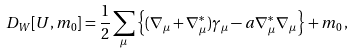<formula> <loc_0><loc_0><loc_500><loc_500>D _ { W } [ U , m _ { 0 } ] = \frac { 1 } { 2 } \sum _ { \mu } \left \{ ( \nabla _ { \mu } + \nabla _ { \mu } ^ { * } ) \gamma _ { \mu } - a \nabla _ { \mu } ^ { * } \nabla _ { \mu } \right \} + m _ { 0 } \, ,</formula> 